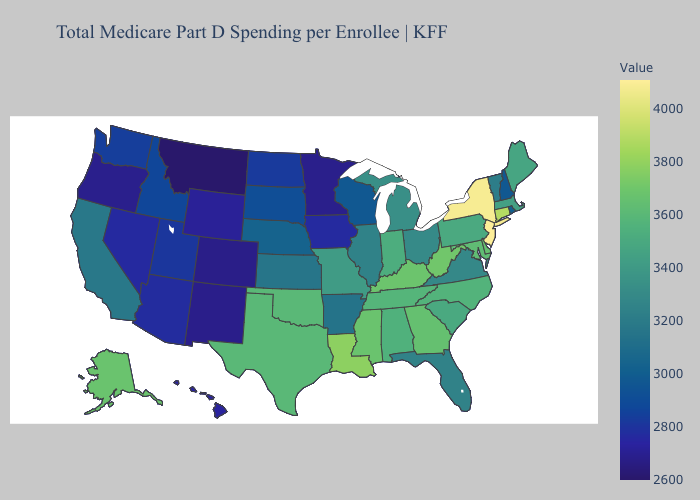Does New Mexico have the lowest value in the USA?
Answer briefly. No. Among the states that border New Mexico , does Oklahoma have the lowest value?
Answer briefly. No. Among the states that border Michigan , which have the lowest value?
Keep it brief. Wisconsin. Does Pennsylvania have a higher value than Wisconsin?
Concise answer only. Yes. Is the legend a continuous bar?
Answer briefly. Yes. Does Wyoming have a higher value than Rhode Island?
Short answer required. No. 